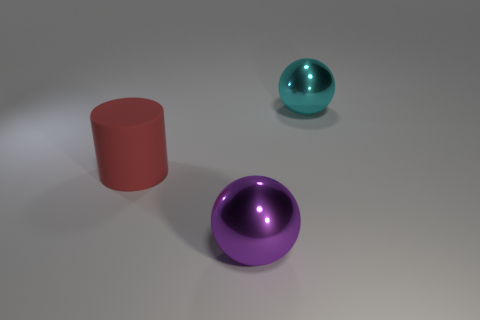Is there anything else that is the same material as the big cylinder?
Make the answer very short. No. Is the shape of the cyan metallic object the same as the large rubber thing?
Your answer should be very brief. No. What color is the large sphere that is made of the same material as the large purple thing?
Your response must be concise. Cyan. How many objects are big spheres in front of the big cylinder or matte cylinders?
Ensure brevity in your answer.  2. What is the color of the big sphere on the right side of the big ball in front of the red thing?
Ensure brevity in your answer.  Cyan. How many other things are there of the same color as the large matte thing?
Provide a short and direct response. 0. The red object has what size?
Offer a very short reply. Large. Is the number of big metallic spheres in front of the rubber object greater than the number of rubber things behind the big cyan thing?
Make the answer very short. Yes. How many big matte cylinders are in front of the metal sphere behind the large cylinder?
Your answer should be very brief. 1. Is the shape of the big shiny thing that is behind the red matte thing the same as  the big purple metal object?
Offer a terse response. Yes. 